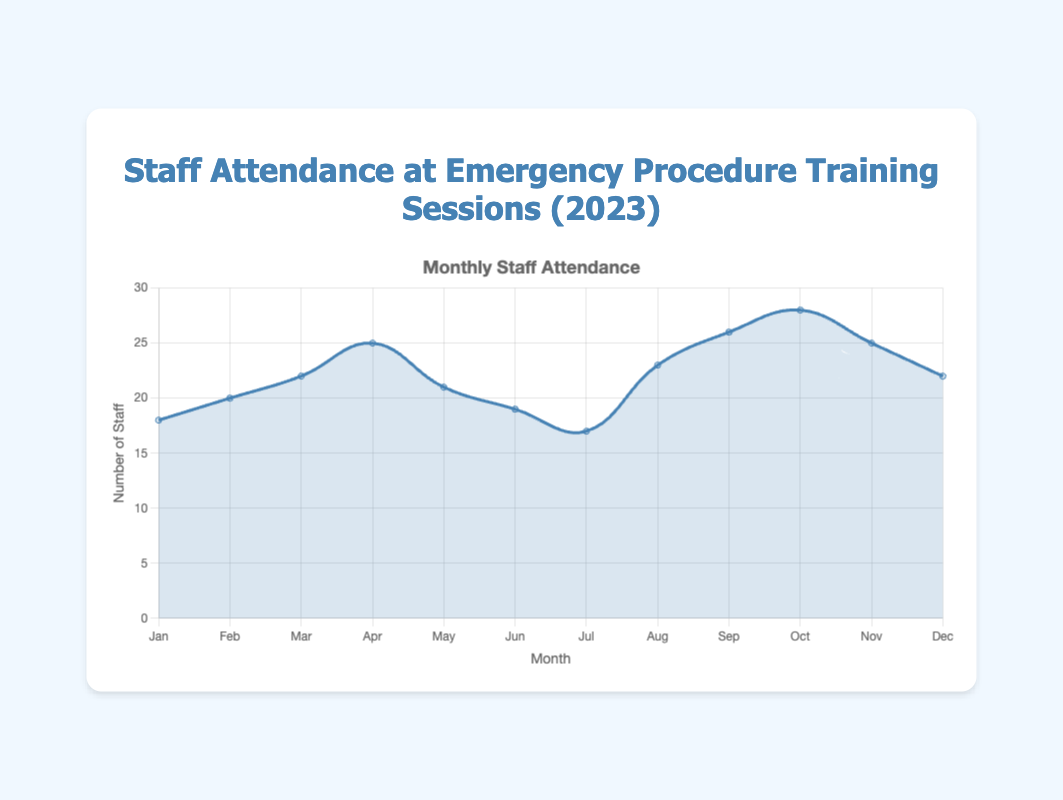What's the title of the chart? The title is displayed at the top of the chart, and it reads "Staff Attendance at Emergency Procedure Training Sessions (2023)".
Answer: Staff Attendance at Emergency Procedure Training Sessions (2023) What is the highest monthly attendance? To find the highest monthly attendance, look for the peak in the area chart where the line reaches its highest point. The highest point is in October with an attendance of 28 staff members.
Answer: October What is the trend of staff attendance from January to April? Analyze the area chart from January to April. The chart shows a general upward trend in staff attendance, starting from 18 in January and increasing to 25 in April.
Answer: Upward trend Compare the staff attendance between February and June. Which month had higher attendance and by how much? The attendance in February was 20, while the attendance in June was 19. Therefore, February had a higher attendance by 1 staff member.
Answer: February, by 1 What is the total staff attendance from May to August? To find the total, add the attendance figures for May (21), June (19), July (17), and August (23). The sum is 21 + 19 + 17 + 23 = 80.
Answer: 80 Which month showed the largest increase in staff attendance compared to the previous month? To determine the largest increase, compare the month-on-month differences. The largest increase was from July (17) to August (23), which is an increase of 6 staff members.
Answer: August How does the staff attendance in December compare to January? In January, the attendance was 18, and in December, it was 22. December had higher attendance by 4 staff members.
Answer: December, by 4 What is the median staff attendance for the year? Arrange the attendance values in ascending order and find the middle value. The sorted values are [17, 18, 19, 20, 21, 22, 22, 23, 25, 25, 26, 28]. The median, being the average of the 6th and 7th values, is (22 + 22)/2 = 22.
Answer: 22 Describe the overall trend in staff attendance throughout the year. Observe the entire area chart. There is an initial rise from January to April, a slight drop in May and through to July, a peak in attendance in October, and a slight decline by December. The overall trend fluctuates but with an increase toward the end.
Answer: Fluctuating with an increase towards the end Which month had the lowest attendance, and what was the attendance? Look for the lowest point in the area chart. July shows the lowest attendance, which was 17 staff members.
Answer: July, 17 